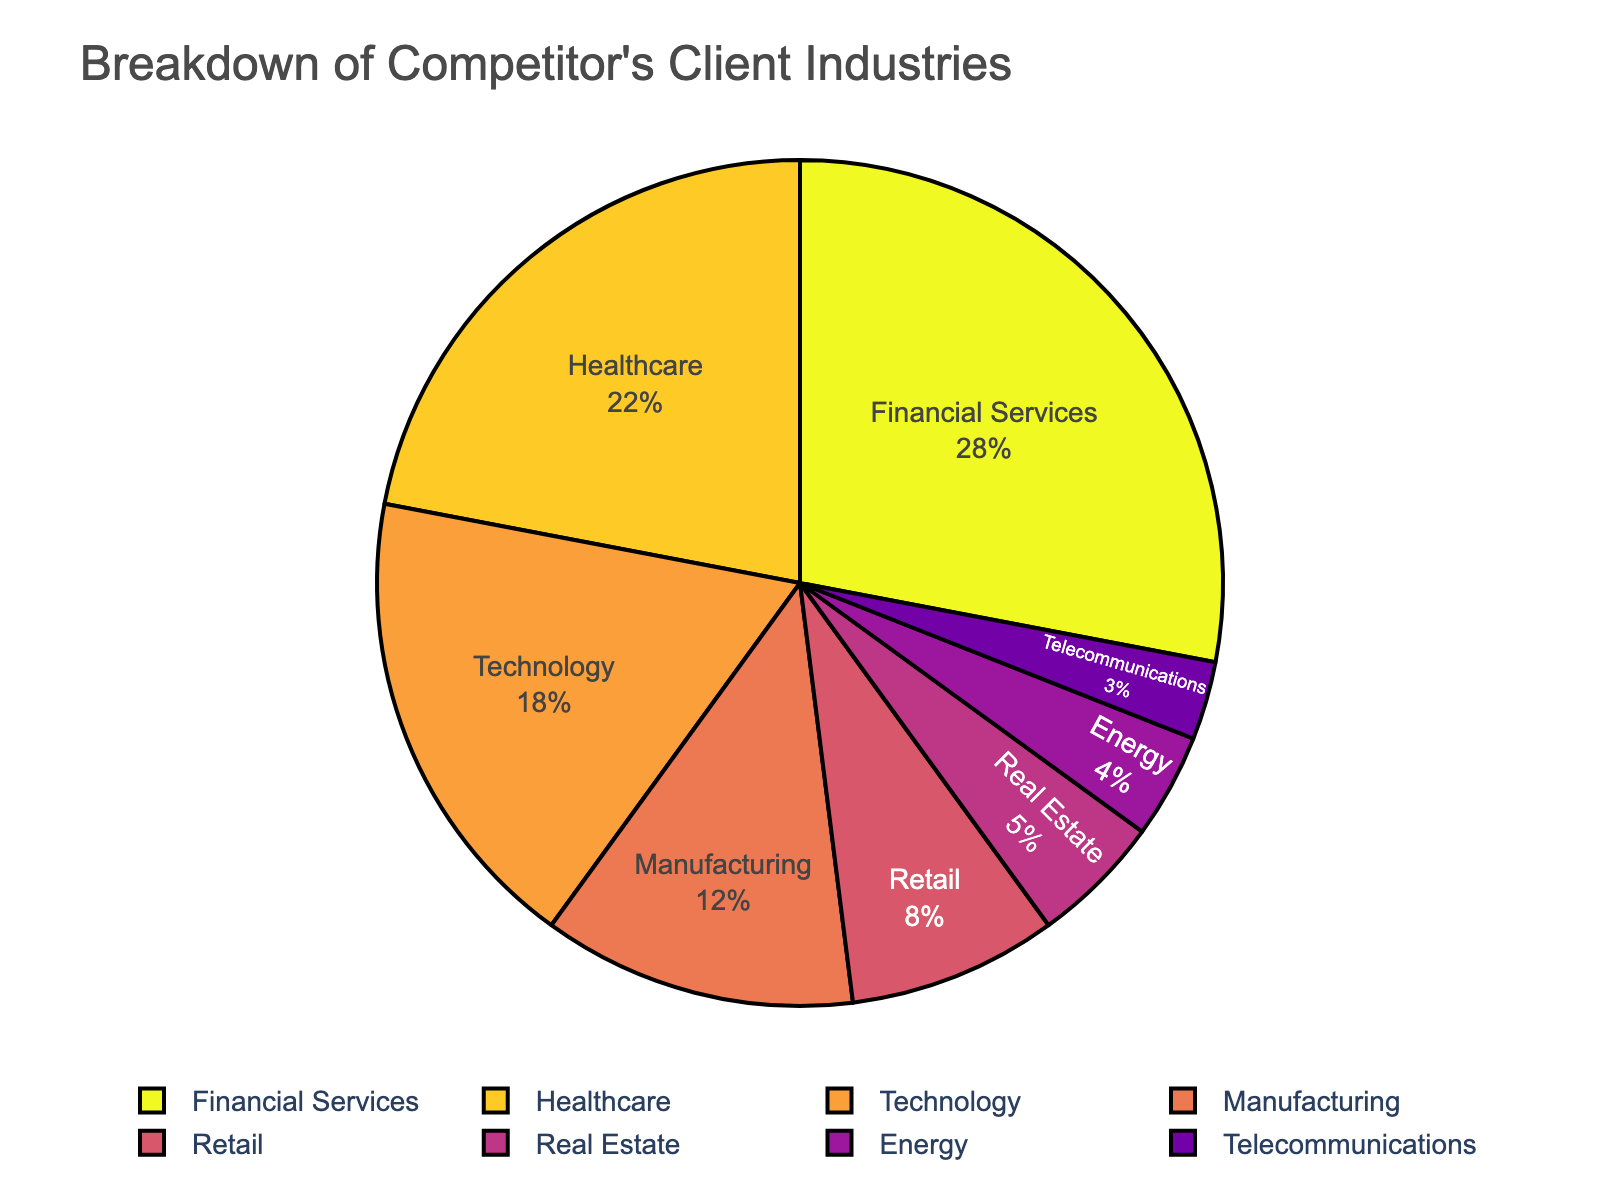what percentage of the competitor's client industries does the combination of healthcare and technology comprise? The pie chart shows that Healthcare comprises 22% and Technology comprises 18%. Summing these percentages gives 22% + 18% = 40%.
Answer: 40% By how much does the financial services sector exceed the retail sector in terms of client percentage? The pie chart indicates that Financial Services is at 28% and Retail at 8%. Calculating the difference: 28% - 8% = 20%.
Answer: 20% Is the manufacturing sector's client percentage greater than or less than that of the technology sector? The pie chart shows Manufacturing at 12% and Technology at 18%. Comparing the two: Manufacturing (12%) is less than Technology (18%).
Answer: Less than What percentage of the competitor's client industries is covered by the non-top three industries? The pie chart shows the top three industries as Financial Services (28%), Healthcare (22%), and Technology (18%), which sum up to 28% + 22% + 18% = 68%. The remaining industries sum up to 100% - 68% = 32%.
Answer: 32% How much more significant is the financial services sector compared to the least represented sector, telecommunications? Financial Services is at 28% and Telecommunications at 3%. Calculating the difference: 28% - 3% = 25%.
Answer: 25% What's the combined percentage of the energy and real estate sectors? The pie chart shows Energy at 4% and Real Estate at 5%. Summing these gives 4% + 5% = 9%.
Answer: 9% How many sectors have a client percentage of more than 10%? The pie chart shows sectors: Financial Services (28%), Healthcare (22%), Technology (18%), and Manufacturing (12%) all greater than 10%. Counting these gives 4 sectors.
Answer: 4 Which industry has the smallest portion of the pie chart, and what is its percentage? The pie chart indicates that Telecommunications has the smallest portion, with a percentage of 3%.
Answer: Telecommunications, 3% Which sectors combined have a greater percentage than the healthcare sector alone? Combining the percentages for Manufacturing (12%), Retail (8%), Real Estate (5%), Energy (4%), and Telecommunications (3%) gives 12% + 8% + 5% + 4% + 3% = 32%, which is greater than Healthcare (22%).
Answer: Manufacturing, Retail, Real Estate, Energy, Telecommunications Does the technology sector have a higher or lower client percentage than the total combination of retail, real estate, and energy? Retail (8%), Real Estate (5%), and Energy (4%) combined give 8% + 5% + 4% = 17%, which is lower than Technology (18%).
Answer: Higher 